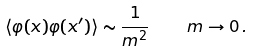<formula> <loc_0><loc_0><loc_500><loc_500>\langle \varphi ( x ) \varphi ( x ^ { \prime } ) \rangle \sim \frac { 1 } { m ^ { 2 } } \, \quad m \to 0 \, .</formula> 